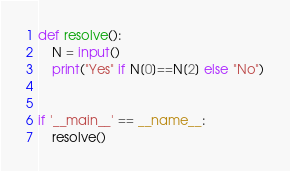<code> <loc_0><loc_0><loc_500><loc_500><_Python_>
def resolve():
    N = input()
    print("Yes" if N[0]==N[2] else "No")


if '__main__' == __name__:
    resolve()</code> 